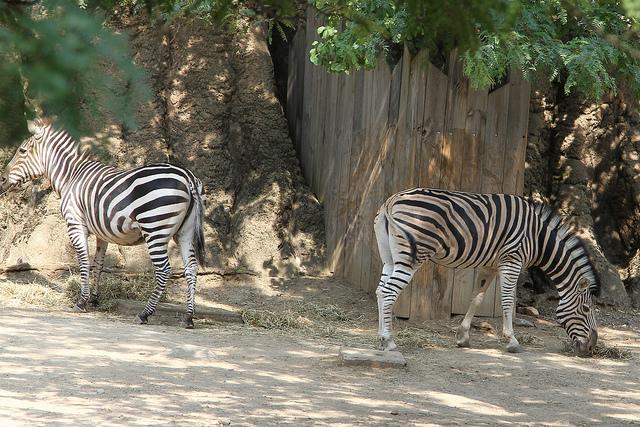Do the zebras face each other?
Short answer required. No. How many zebras are there?
Give a very brief answer. 2. Are the zebras in their natural habitat?
Answer briefly. No. Which direction is the zebra in the foreground facing?
Concise answer only. Right. 